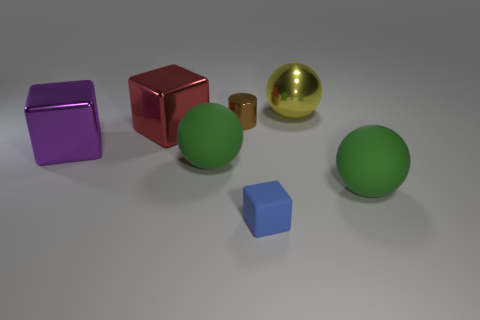Add 2 red shiny cubes. How many objects exist? 9 Subtract all cylinders. How many objects are left? 6 Add 3 big green rubber things. How many big green rubber things are left? 5 Add 7 small red balls. How many small red balls exist? 7 Subtract 0 cyan cylinders. How many objects are left? 7 Subtract all tiny cubes. Subtract all cylinders. How many objects are left? 5 